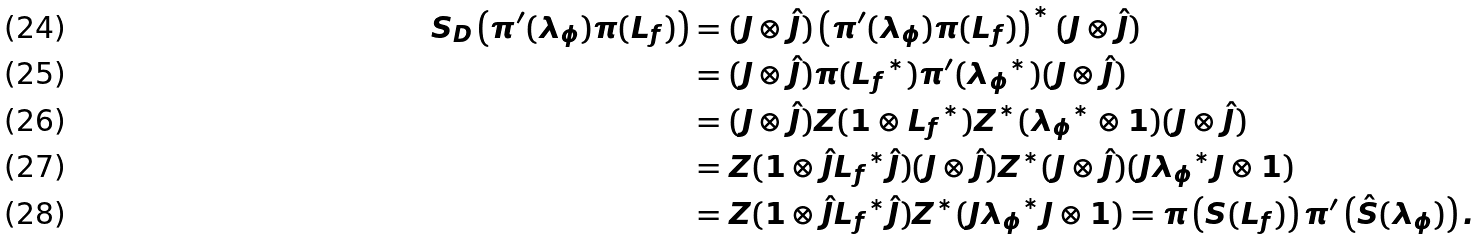<formula> <loc_0><loc_0><loc_500><loc_500>S _ { D } \left ( \pi ^ { \prime } ( \lambda _ { \phi } ) \pi ( L _ { f } ) \right ) & = ( J \otimes \hat { J } ) \left ( \pi ^ { \prime } ( \lambda _ { \phi } ) \pi ( L _ { f } ) \right ) ^ { * } ( J \otimes \hat { J } ) \\ & = ( J \otimes \hat { J } ) \pi ( { L _ { f } } ^ { * } ) \pi ^ { \prime } ( { \lambda _ { \phi } } ^ { * } ) ( J \otimes \hat { J } ) \\ & = ( J \otimes \hat { J } ) Z ( 1 \otimes { L _ { f } } ^ { * } ) Z ^ { * } ( { \lambda _ { \phi } } ^ { * } \otimes 1 ) ( J \otimes \hat { J } ) \\ & = Z ( 1 \otimes \hat { J } { L _ { f } } ^ { * } \hat { J } ) ( J \otimes \hat { J } ) Z ^ { * } ( J \otimes \hat { J } ) ( J { \lambda _ { \phi } } ^ { * } J \otimes 1 ) \\ & = Z ( 1 \otimes \hat { J } { L _ { f } } ^ { * } \hat { J } ) Z ^ { * } ( J { \lambda _ { \phi } } ^ { * } J \otimes 1 ) = \pi \left ( S ( L _ { f } ) \right ) \pi ^ { \prime } \left ( \hat { S } ( \lambda _ { \phi } ) \right ) .</formula> 